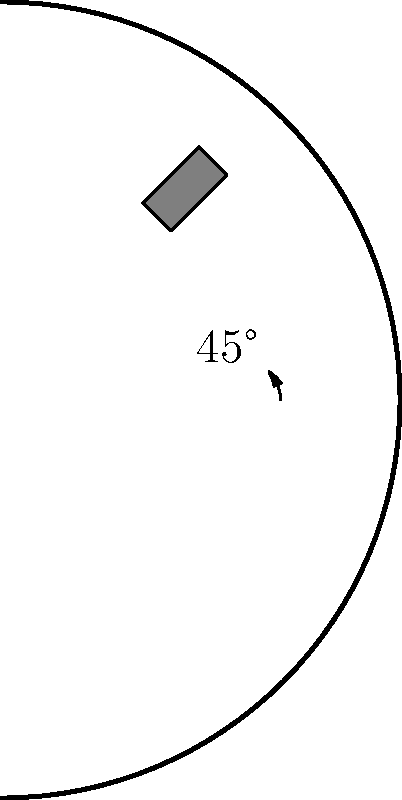A custom car decal for a vintage sports car needs to be rotated to fit on a curved fender. If the original rectangular decal is rotated 45° clockwise to align with the fender's curve, what transformation should be applied to return the decal to its original orientation? To solve this problem, we need to consider the properties of rotational transformations:

1. The decal has been rotated 45° clockwise from its original position.
2. Rotations are reversible transformations.
3. To undo a clockwise rotation, we need to apply a counterclockwise rotation of the same magnitude.

Step 1: Identify the original transformation
- The decal was rotated 45° clockwise.

Step 2: Determine the inverse transformation
- To reverse a clockwise rotation, we need to rotate counterclockwise.
- The magnitude of the rotation should be the same as the original (45°).

Step 3: Express the transformation mathematically
- In mathematical notation, we can express this as a rotation of -45° (negative angle indicates counterclockwise rotation).
- In transformation geometry, this would be written as $R_{-45°}$ or $R_{-\frac{\pi}{4}}$ in radians.

Therefore, to return the decal to its original orientation, we need to apply a 45° counterclockwise rotation.
Answer: 45° counterclockwise rotation 